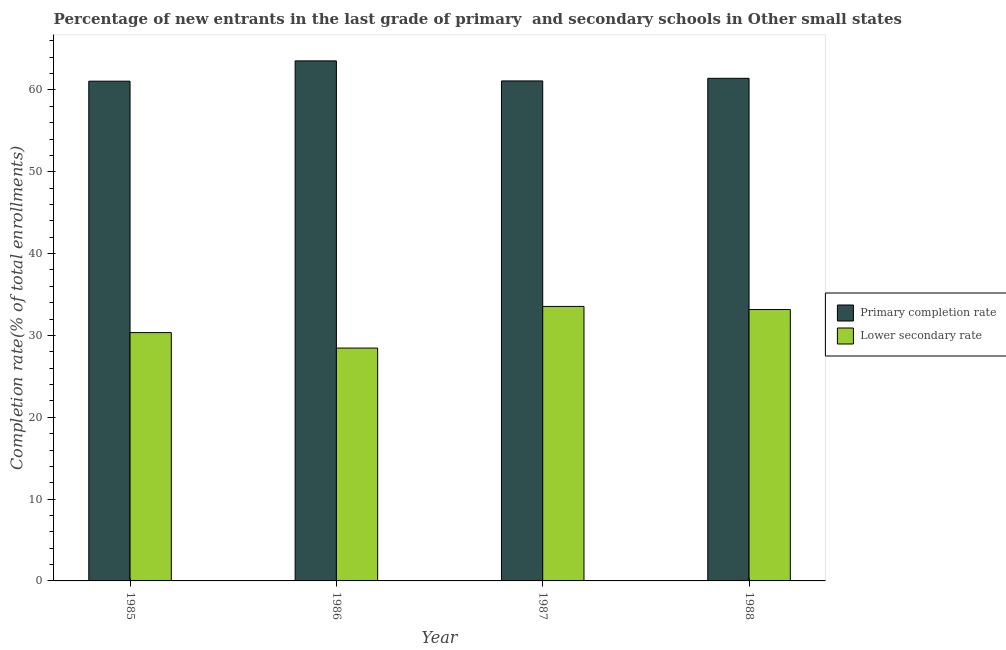How many different coloured bars are there?
Give a very brief answer. 2. How many bars are there on the 3rd tick from the left?
Your answer should be very brief. 2. How many bars are there on the 2nd tick from the right?
Your answer should be very brief. 2. What is the completion rate in primary schools in 1986?
Make the answer very short. 63.56. Across all years, what is the maximum completion rate in secondary schools?
Give a very brief answer. 33.55. Across all years, what is the minimum completion rate in secondary schools?
Offer a terse response. 28.46. In which year was the completion rate in secondary schools maximum?
Ensure brevity in your answer.  1987. In which year was the completion rate in secondary schools minimum?
Provide a succinct answer. 1986. What is the total completion rate in secondary schools in the graph?
Offer a very short reply. 125.52. What is the difference between the completion rate in primary schools in 1986 and that in 1987?
Your response must be concise. 2.45. What is the difference between the completion rate in secondary schools in 1988 and the completion rate in primary schools in 1985?
Offer a very short reply. 2.82. What is the average completion rate in primary schools per year?
Your response must be concise. 61.79. In how many years, is the completion rate in primary schools greater than 64 %?
Offer a very short reply. 0. What is the ratio of the completion rate in primary schools in 1985 to that in 1987?
Make the answer very short. 1. What is the difference between the highest and the second highest completion rate in primary schools?
Provide a short and direct response. 2.13. What is the difference between the highest and the lowest completion rate in primary schools?
Offer a very short reply. 2.48. In how many years, is the completion rate in primary schools greater than the average completion rate in primary schools taken over all years?
Your answer should be very brief. 1. What does the 2nd bar from the left in 1985 represents?
Your answer should be compact. Lower secondary rate. What does the 2nd bar from the right in 1988 represents?
Ensure brevity in your answer.  Primary completion rate. Are the values on the major ticks of Y-axis written in scientific E-notation?
Make the answer very short. No. How are the legend labels stacked?
Your answer should be compact. Vertical. What is the title of the graph?
Your answer should be very brief. Percentage of new entrants in the last grade of primary  and secondary schools in Other small states. Does "current US$" appear as one of the legend labels in the graph?
Your response must be concise. No. What is the label or title of the Y-axis?
Your answer should be compact. Completion rate(% of total enrollments). What is the Completion rate(% of total enrollments) of Primary completion rate in 1985?
Keep it short and to the point. 61.08. What is the Completion rate(% of total enrollments) in Lower secondary rate in 1985?
Your response must be concise. 30.35. What is the Completion rate(% of total enrollments) of Primary completion rate in 1986?
Your response must be concise. 63.56. What is the Completion rate(% of total enrollments) of Lower secondary rate in 1986?
Ensure brevity in your answer.  28.46. What is the Completion rate(% of total enrollments) in Primary completion rate in 1987?
Your response must be concise. 61.11. What is the Completion rate(% of total enrollments) of Lower secondary rate in 1987?
Provide a short and direct response. 33.55. What is the Completion rate(% of total enrollments) in Primary completion rate in 1988?
Offer a very short reply. 61.43. What is the Completion rate(% of total enrollments) in Lower secondary rate in 1988?
Provide a short and direct response. 33.17. Across all years, what is the maximum Completion rate(% of total enrollments) in Primary completion rate?
Provide a succinct answer. 63.56. Across all years, what is the maximum Completion rate(% of total enrollments) of Lower secondary rate?
Your answer should be compact. 33.55. Across all years, what is the minimum Completion rate(% of total enrollments) in Primary completion rate?
Provide a short and direct response. 61.08. Across all years, what is the minimum Completion rate(% of total enrollments) in Lower secondary rate?
Ensure brevity in your answer.  28.46. What is the total Completion rate(% of total enrollments) of Primary completion rate in the graph?
Your response must be concise. 247.17. What is the total Completion rate(% of total enrollments) in Lower secondary rate in the graph?
Make the answer very short. 125.52. What is the difference between the Completion rate(% of total enrollments) of Primary completion rate in 1985 and that in 1986?
Your response must be concise. -2.48. What is the difference between the Completion rate(% of total enrollments) of Lower secondary rate in 1985 and that in 1986?
Offer a very short reply. 1.89. What is the difference between the Completion rate(% of total enrollments) of Primary completion rate in 1985 and that in 1987?
Offer a terse response. -0.03. What is the difference between the Completion rate(% of total enrollments) of Lower secondary rate in 1985 and that in 1987?
Your answer should be very brief. -3.2. What is the difference between the Completion rate(% of total enrollments) in Primary completion rate in 1985 and that in 1988?
Give a very brief answer. -0.35. What is the difference between the Completion rate(% of total enrollments) of Lower secondary rate in 1985 and that in 1988?
Offer a very short reply. -2.82. What is the difference between the Completion rate(% of total enrollments) of Primary completion rate in 1986 and that in 1987?
Make the answer very short. 2.45. What is the difference between the Completion rate(% of total enrollments) of Lower secondary rate in 1986 and that in 1987?
Ensure brevity in your answer.  -5.09. What is the difference between the Completion rate(% of total enrollments) of Primary completion rate in 1986 and that in 1988?
Ensure brevity in your answer.  2.13. What is the difference between the Completion rate(% of total enrollments) of Lower secondary rate in 1986 and that in 1988?
Keep it short and to the point. -4.71. What is the difference between the Completion rate(% of total enrollments) in Primary completion rate in 1987 and that in 1988?
Provide a short and direct response. -0.32. What is the difference between the Completion rate(% of total enrollments) in Lower secondary rate in 1987 and that in 1988?
Offer a terse response. 0.38. What is the difference between the Completion rate(% of total enrollments) in Primary completion rate in 1985 and the Completion rate(% of total enrollments) in Lower secondary rate in 1986?
Make the answer very short. 32.62. What is the difference between the Completion rate(% of total enrollments) in Primary completion rate in 1985 and the Completion rate(% of total enrollments) in Lower secondary rate in 1987?
Give a very brief answer. 27.53. What is the difference between the Completion rate(% of total enrollments) of Primary completion rate in 1985 and the Completion rate(% of total enrollments) of Lower secondary rate in 1988?
Ensure brevity in your answer.  27.91. What is the difference between the Completion rate(% of total enrollments) of Primary completion rate in 1986 and the Completion rate(% of total enrollments) of Lower secondary rate in 1987?
Make the answer very short. 30.01. What is the difference between the Completion rate(% of total enrollments) in Primary completion rate in 1986 and the Completion rate(% of total enrollments) in Lower secondary rate in 1988?
Ensure brevity in your answer.  30.39. What is the difference between the Completion rate(% of total enrollments) of Primary completion rate in 1987 and the Completion rate(% of total enrollments) of Lower secondary rate in 1988?
Provide a succinct answer. 27.94. What is the average Completion rate(% of total enrollments) of Primary completion rate per year?
Your answer should be compact. 61.79. What is the average Completion rate(% of total enrollments) of Lower secondary rate per year?
Offer a terse response. 31.38. In the year 1985, what is the difference between the Completion rate(% of total enrollments) of Primary completion rate and Completion rate(% of total enrollments) of Lower secondary rate?
Provide a short and direct response. 30.73. In the year 1986, what is the difference between the Completion rate(% of total enrollments) of Primary completion rate and Completion rate(% of total enrollments) of Lower secondary rate?
Ensure brevity in your answer.  35.1. In the year 1987, what is the difference between the Completion rate(% of total enrollments) in Primary completion rate and Completion rate(% of total enrollments) in Lower secondary rate?
Provide a succinct answer. 27.56. In the year 1988, what is the difference between the Completion rate(% of total enrollments) in Primary completion rate and Completion rate(% of total enrollments) in Lower secondary rate?
Offer a terse response. 28.26. What is the ratio of the Completion rate(% of total enrollments) in Primary completion rate in 1985 to that in 1986?
Make the answer very short. 0.96. What is the ratio of the Completion rate(% of total enrollments) in Lower secondary rate in 1985 to that in 1986?
Offer a very short reply. 1.07. What is the ratio of the Completion rate(% of total enrollments) in Primary completion rate in 1985 to that in 1987?
Keep it short and to the point. 1. What is the ratio of the Completion rate(% of total enrollments) in Lower secondary rate in 1985 to that in 1987?
Provide a short and direct response. 0.9. What is the ratio of the Completion rate(% of total enrollments) of Primary completion rate in 1985 to that in 1988?
Your answer should be very brief. 0.99. What is the ratio of the Completion rate(% of total enrollments) in Lower secondary rate in 1985 to that in 1988?
Provide a succinct answer. 0.92. What is the ratio of the Completion rate(% of total enrollments) of Primary completion rate in 1986 to that in 1987?
Offer a very short reply. 1.04. What is the ratio of the Completion rate(% of total enrollments) of Lower secondary rate in 1986 to that in 1987?
Your answer should be compact. 0.85. What is the ratio of the Completion rate(% of total enrollments) in Primary completion rate in 1986 to that in 1988?
Your answer should be very brief. 1.03. What is the ratio of the Completion rate(% of total enrollments) in Lower secondary rate in 1986 to that in 1988?
Your response must be concise. 0.86. What is the ratio of the Completion rate(% of total enrollments) in Primary completion rate in 1987 to that in 1988?
Offer a terse response. 0.99. What is the ratio of the Completion rate(% of total enrollments) of Lower secondary rate in 1987 to that in 1988?
Offer a terse response. 1.01. What is the difference between the highest and the second highest Completion rate(% of total enrollments) of Primary completion rate?
Offer a terse response. 2.13. What is the difference between the highest and the second highest Completion rate(% of total enrollments) in Lower secondary rate?
Your response must be concise. 0.38. What is the difference between the highest and the lowest Completion rate(% of total enrollments) in Primary completion rate?
Your answer should be very brief. 2.48. What is the difference between the highest and the lowest Completion rate(% of total enrollments) of Lower secondary rate?
Your response must be concise. 5.09. 